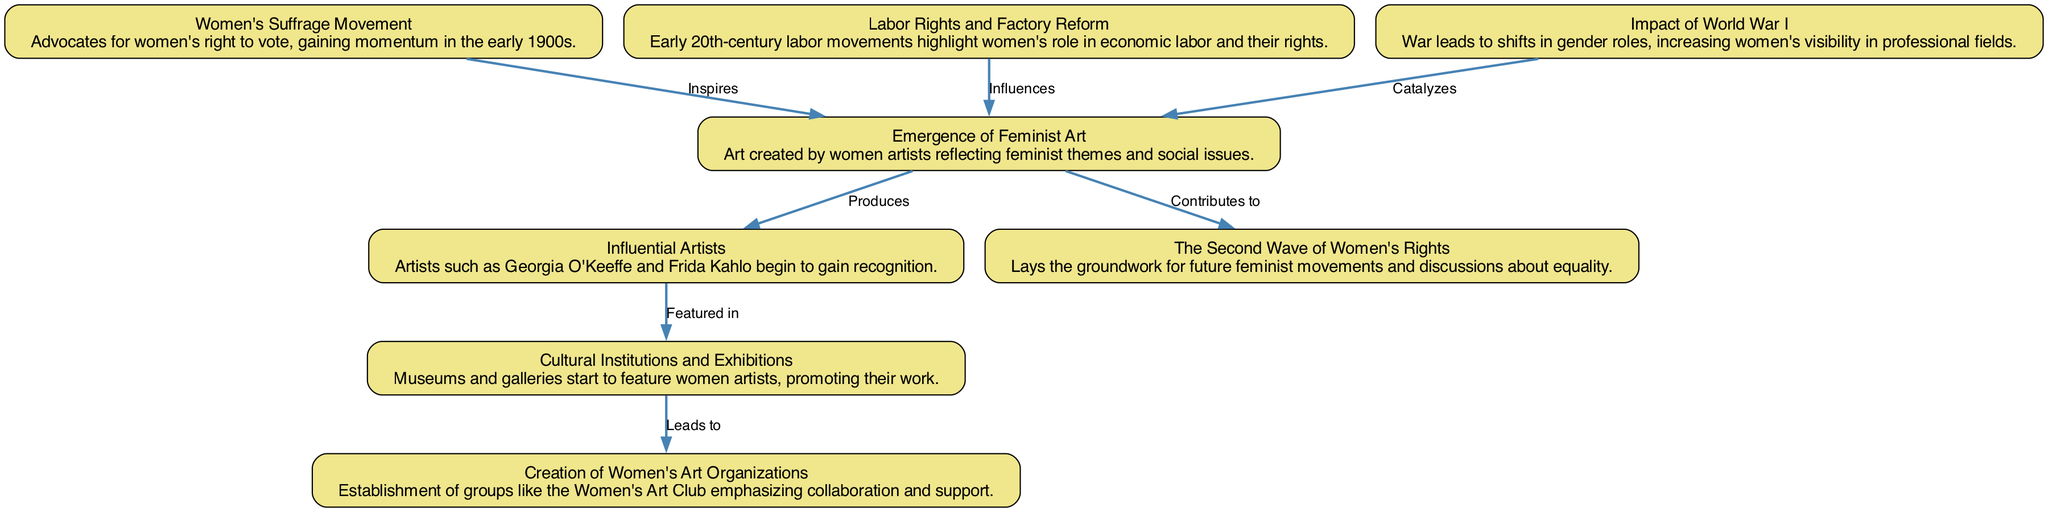What is the first node in the flow chart? The first node in the flow chart is labeled "Women's Suffrage Movement," which is the starting point of the relationships illustrated in the diagram.
Answer: Women's Suffrage Movement How many nodes are present in the flow chart? To determine the number of nodes, we count each unique element listed in the diagram, which totals to eight distinct nodes.
Answer: 8 What relationship exists between the "Women's Suffrage Movement" and "Emergence of Feminist Art"? The flow chart indicates that the "Women's Suffrage Movement" inspires the "Emergence of Feminist Art," showing a direct connection of influence from one to the other.
Answer: Inspires Which node is affected by the impact of World War I? According to the flow chart, the "Impact of World War I" catalyzes the "Emergence of Feminist Art," linking the two concepts directly in the diagram.
Answer: Emergence of Feminist Art What is the outcome of "Emergence of Feminist Art" on "The Second Wave of Women's Rights"? The flow chart illustrates that the "Emergence of Feminist Art" contributes to "The Second Wave of Women's Rights," indicating that the former plays a role in developing the latter.
Answer: Contributes to What connects "Cultural Institutions and Exhibitions" and "Creation of Women's Art Organizations"? The diagram shows that "Cultural Institutions and Exhibitions" leads to the "Creation of Women's Art Organizations," establishing a flow from one to another that indicates a causative relationship.
Answer: Leads to Which influential artist is mentioned in the flow chart? The flow chart lists "Georgia O'Keeffe" and "Frida Kahlo" as influential artists, both of whom are noted for gaining recognition in the early 20th century within the context of feminist art.
Answer: Georgia O'Keeffe and Frida Kahlo What precedes the "Emergence of Feminist Art" in the diagram? The diagram indicates that both the "Women's Suffrage Movement" and "Labor Rights and Factory Reform" precede the "Emergence of Feminist Art," showing that multiple movements influence its development.
Answer: Women's Suffrage Movement and Labor Rights and Factory Reform How does "Labor Rights and Factory Reform" relate to "Emergence of Feminist Art"? The flow chart indicates that "Labor Rights and Factory Reform" influences the "Emergence of Feminist Art," illustrating a connection that highlights the economic context in which this art emerges.
Answer: Influences 